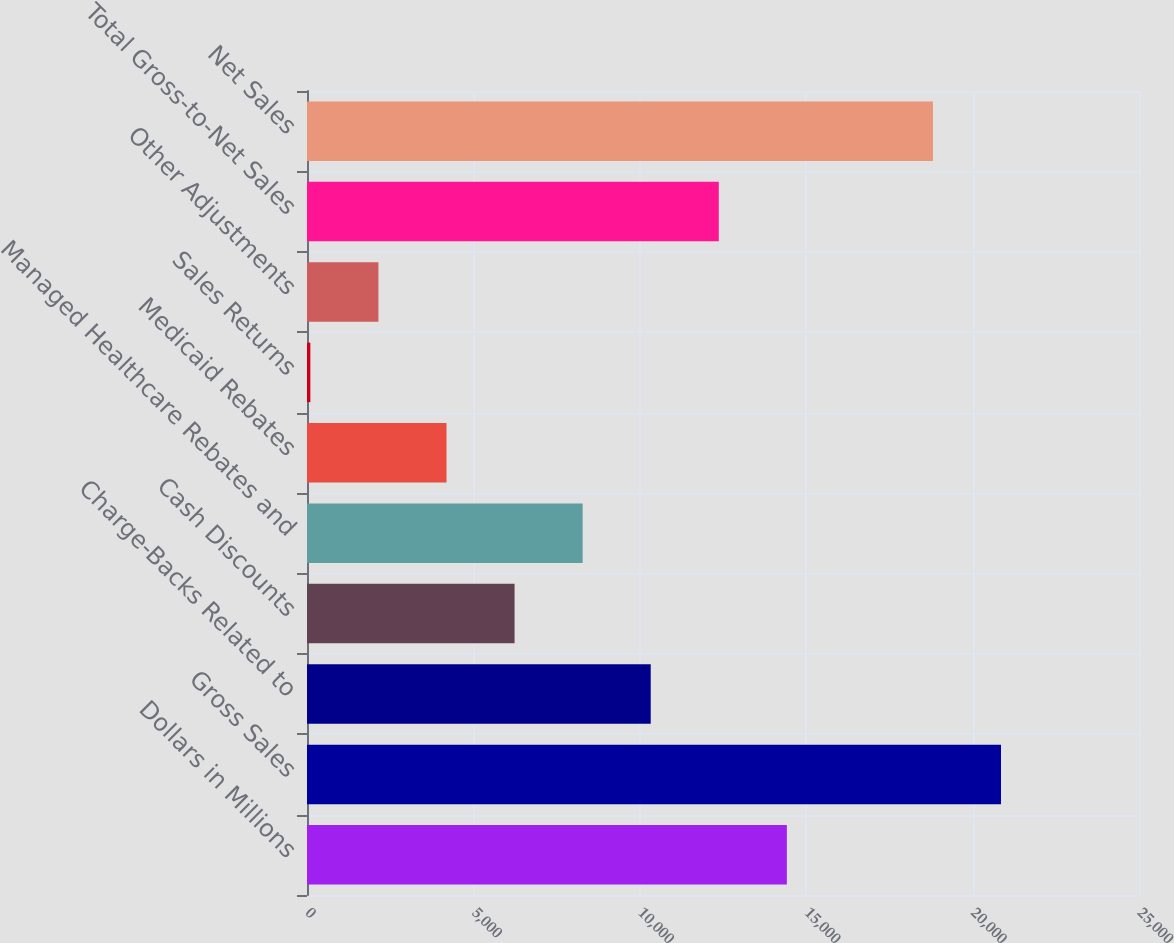<chart> <loc_0><loc_0><loc_500><loc_500><bar_chart><fcel>Dollars in Millions<fcel>Gross Sales<fcel>Charge-Backs Related to<fcel>Cash Discounts<fcel>Managed Healthcare Rebates and<fcel>Medicaid Rebates<fcel>Sales Returns<fcel>Other Adjustments<fcel>Total Gross-to-Net Sales<fcel>Net Sales<nl><fcel>14418.8<fcel>20853.4<fcel>10328<fcel>6237.2<fcel>8282.6<fcel>4191.8<fcel>101<fcel>2146.4<fcel>12373.4<fcel>18808<nl></chart> 